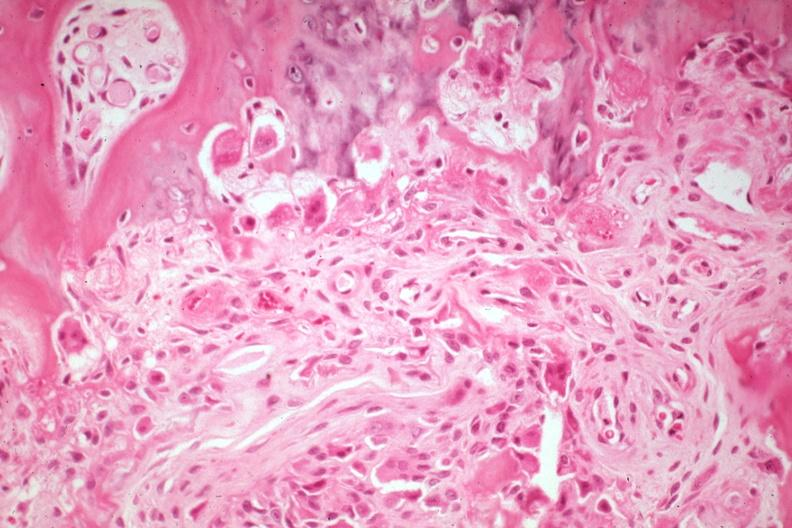s joints present?
Answer the question using a single word or phrase. Yes 